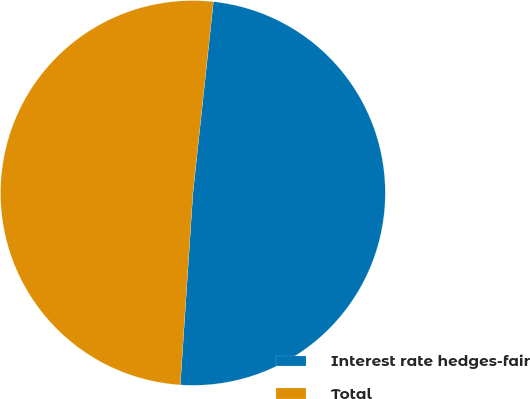Convert chart. <chart><loc_0><loc_0><loc_500><loc_500><pie_chart><fcel>Interest rate hedges-fair<fcel>Total<nl><fcel>49.35%<fcel>50.65%<nl></chart> 